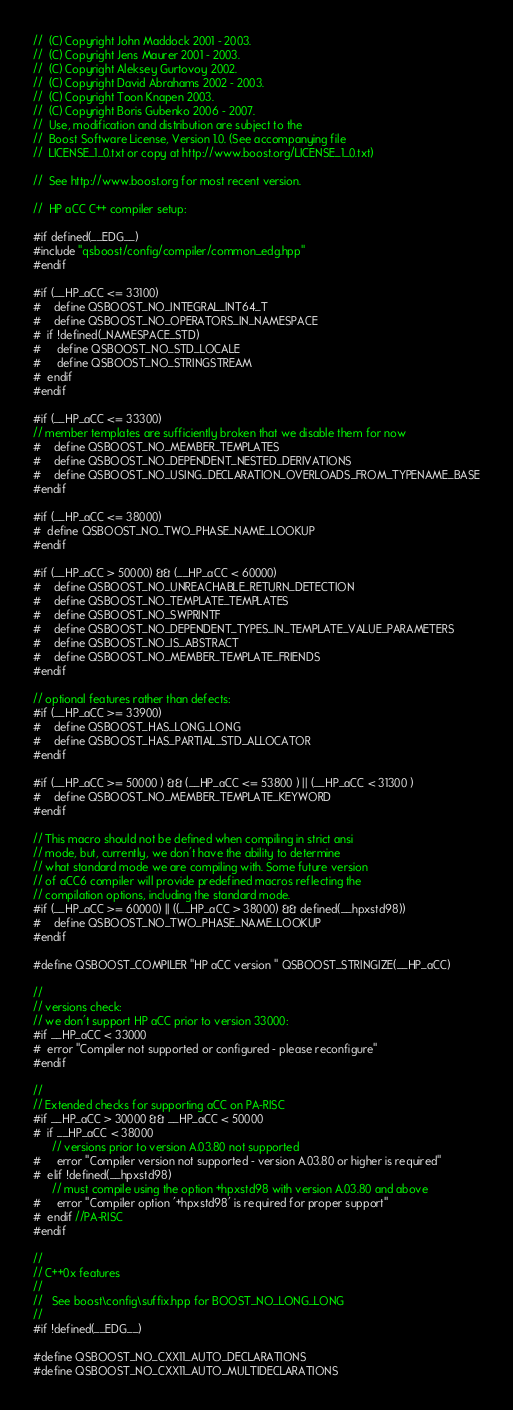<code> <loc_0><loc_0><loc_500><loc_500><_C++_>//  (C) Copyright John Maddock 2001 - 2003.
//  (C) Copyright Jens Maurer 2001 - 2003.
//  (C) Copyright Aleksey Gurtovoy 2002.
//  (C) Copyright David Abrahams 2002 - 2003.
//  (C) Copyright Toon Knapen 2003.
//  (C) Copyright Boris Gubenko 2006 - 2007.
//  Use, modification and distribution are subject to the
//  Boost Software License, Version 1.0. (See accompanying file
//  LICENSE_1_0.txt or copy at http://www.boost.org/LICENSE_1_0.txt)

//  See http://www.boost.org for most recent version.

//  HP aCC C++ compiler setup:

#if defined(__EDG__)
#include "qsboost/config/compiler/common_edg.hpp"
#endif

#if (__HP_aCC <= 33100)
#    define QSBOOST_NO_INTEGRAL_INT64_T
#    define QSBOOST_NO_OPERATORS_IN_NAMESPACE
#  if !defined(_NAMESPACE_STD)
#     define QSBOOST_NO_STD_LOCALE
#     define QSBOOST_NO_STRINGSTREAM
#  endif
#endif

#if (__HP_aCC <= 33300)
// member templates are sufficiently broken that we disable them for now
#    define QSBOOST_NO_MEMBER_TEMPLATES
#    define QSBOOST_NO_DEPENDENT_NESTED_DERIVATIONS
#    define QSBOOST_NO_USING_DECLARATION_OVERLOADS_FROM_TYPENAME_BASE
#endif

#if (__HP_aCC <= 38000)
#  define QSBOOST_NO_TWO_PHASE_NAME_LOOKUP
#endif

#if (__HP_aCC > 50000) && (__HP_aCC < 60000)
#    define QSBOOST_NO_UNREACHABLE_RETURN_DETECTION
#    define QSBOOST_NO_TEMPLATE_TEMPLATES
#    define QSBOOST_NO_SWPRINTF
#    define QSBOOST_NO_DEPENDENT_TYPES_IN_TEMPLATE_VALUE_PARAMETERS
#    define QSBOOST_NO_IS_ABSTRACT
#    define QSBOOST_NO_MEMBER_TEMPLATE_FRIENDS
#endif

// optional features rather than defects:
#if (__HP_aCC >= 33900)
#    define QSBOOST_HAS_LONG_LONG
#    define QSBOOST_HAS_PARTIAL_STD_ALLOCATOR
#endif

#if (__HP_aCC >= 50000 ) && (__HP_aCC <= 53800 ) || (__HP_aCC < 31300 )
#    define QSBOOST_NO_MEMBER_TEMPLATE_KEYWORD
#endif

// This macro should not be defined when compiling in strict ansi
// mode, but, currently, we don't have the ability to determine
// what standard mode we are compiling with. Some future version
// of aCC6 compiler will provide predefined macros reflecting the
// compilation options, including the standard mode.
#if (__HP_aCC >= 60000) || ((__HP_aCC > 38000) && defined(__hpxstd98))
#    define QSBOOST_NO_TWO_PHASE_NAME_LOOKUP
#endif

#define QSBOOST_COMPILER "HP aCC version " QSBOOST_STRINGIZE(__HP_aCC)

//
// versions check:
// we don't support HP aCC prior to version 33000:
#if __HP_aCC < 33000
#  error "Compiler not supported or configured - please reconfigure"
#endif

//
// Extended checks for supporting aCC on PA-RISC
#if __HP_aCC > 30000 && __HP_aCC < 50000
#  if __HP_aCC < 38000
      // versions prior to version A.03.80 not supported
#     error "Compiler version not supported - version A.03.80 or higher is required"
#  elif !defined(__hpxstd98)
      // must compile using the option +hpxstd98 with version A.03.80 and above
#     error "Compiler option '+hpxstd98' is required for proper support"
#  endif //PA-RISC
#endif

//
// C++0x features
//
//   See boost\config\suffix.hpp for BOOST_NO_LONG_LONG
//
#if !defined(__EDG__)

#define QSBOOST_NO_CXX11_AUTO_DECLARATIONS
#define QSBOOST_NO_CXX11_AUTO_MULTIDECLARATIONS</code> 